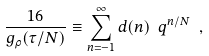<formula> <loc_0><loc_0><loc_500><loc_500>\frac { 1 6 } { g _ { \rho } ( \tau / N ) } \equiv \sum _ { n = - 1 } ^ { \infty } d ( n ) \ q ^ { n / N } \ ,</formula> 